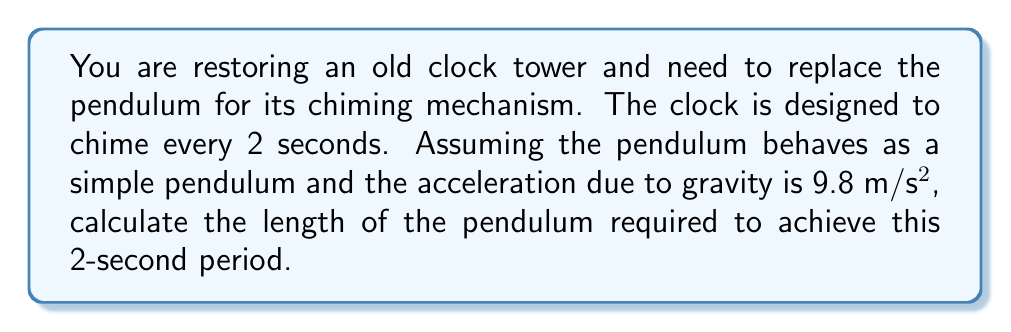Provide a solution to this math problem. To solve this problem, we'll use the formula for the period of a simple pendulum:

$$T = 2\pi \sqrt{\frac{L}{g}}$$

Where:
$T$ = period of oscillation (in seconds)
$L$ = length of the pendulum (in meters)
$g$ = acceleration due to gravity (9.8 m/s²)

Given:
$T = 2$ seconds
$g = 9.8$ m/s²

Step 1: Substitute the known values into the equation:

$$2 = 2\pi \sqrt{\frac{L}{9.8}}$$

Step 2: Square both sides to isolate the square root:

$$4 = 4\pi^2 \frac{L}{9.8}$$

Step 3: Multiply both sides by 9.8:

$$39.2 = 4\pi^2 L$$

Step 4: Divide both sides by $4\pi^2$:

$$L = \frac{39.2}{4\pi^2}$$

Step 5: Calculate the final value:

$$L \approx 0.9936$$ meters

Therefore, the pendulum length required for a 2-second period is approximately 0.9936 meters.
Answer: $0.9936$ m 